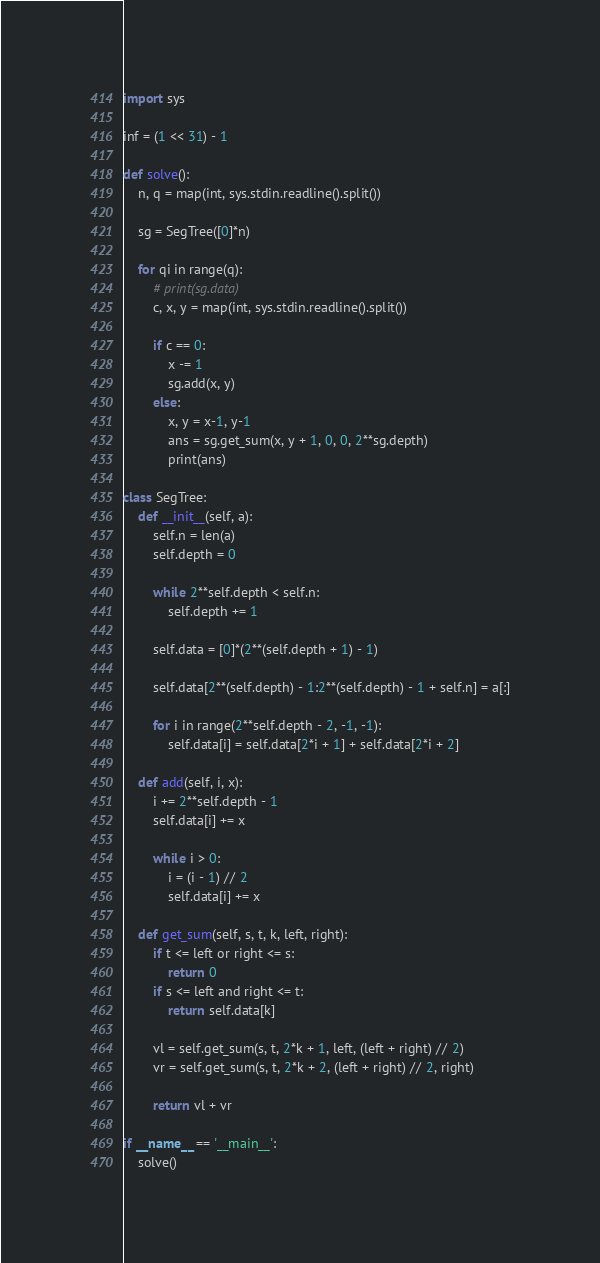Convert code to text. <code><loc_0><loc_0><loc_500><loc_500><_Python_>import sys

inf = (1 << 31) - 1

def solve():
    n, q = map(int, sys.stdin.readline().split())

    sg = SegTree([0]*n)

    for qi in range(q):
        # print(sg.data)
        c, x, y = map(int, sys.stdin.readline().split())

        if c == 0:
            x -= 1
            sg.add(x, y)
        else:
            x, y = x-1, y-1
            ans = sg.get_sum(x, y + 1, 0, 0, 2**sg.depth)
            print(ans)

class SegTree:
    def __init__(self, a):
        self.n = len(a)
        self.depth = 0

        while 2**self.depth < self.n:
            self.depth += 1

        self.data = [0]*(2**(self.depth + 1) - 1)

        self.data[2**(self.depth) - 1:2**(self.depth) - 1 + self.n] = a[:]

        for i in range(2**self.depth - 2, -1, -1):
            self.data[i] = self.data[2*i + 1] + self.data[2*i + 2]

    def add(self, i, x):
        i += 2**self.depth - 1
        self.data[i] += x

        while i > 0:
            i = (i - 1) // 2
            self.data[i] += x

    def get_sum(self, s, t, k, left, right):
        if t <= left or right <= s:
            return 0
        if s <= left and right <= t:
            return self.data[k]

        vl = self.get_sum(s, t, 2*k + 1, left, (left + right) // 2)
        vr = self.get_sum(s, t, 2*k + 2, (left + right) // 2, right)

        return vl + vr

if __name__ == '__main__':
    solve()</code> 